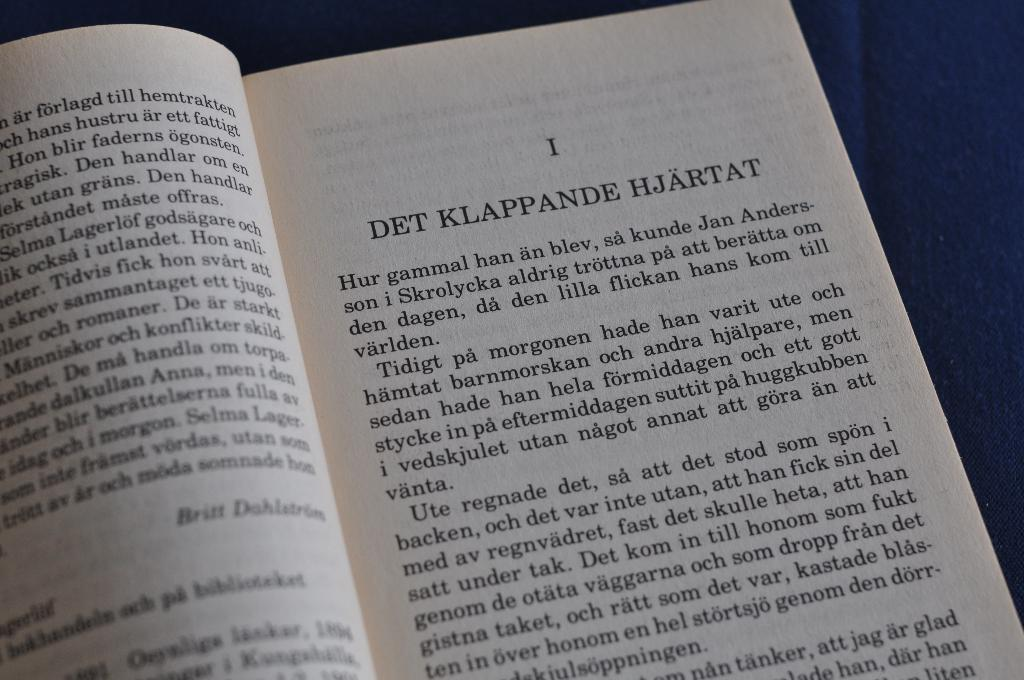Provide a one-sentence caption for the provided image. A new chapter in an open book titled "DET KLAPPANDE HJARTAT". 